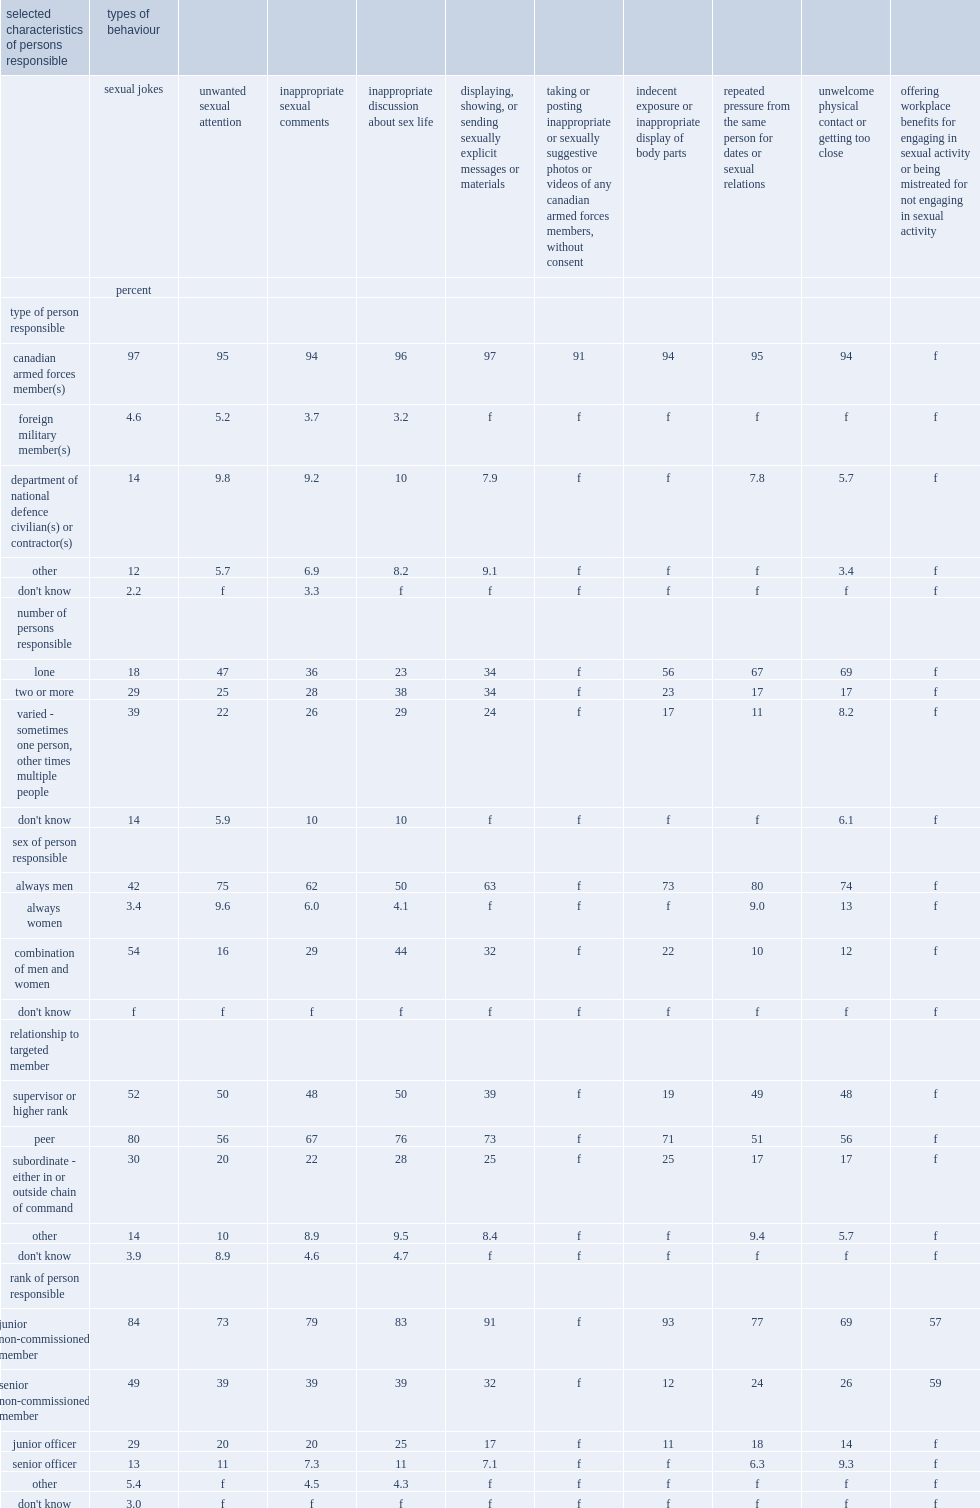What is the percentage of members reported that the person who perpetrated the repeated pressure for dates or sexual relationships that they experienced was always male? 80.0. What is the percentage of members who have personally experienced unwanted sexual attention reporting that the person was always male? 75.0. What is the percentage of reservists who have experienced targeted sexual jokes indicating that a combination of men and women are responsible? 54.0. What is the percentage of reservists who have experienced inappropriate discussion of their sex life indicating that a combination of men and women are responsible? 44.0. Could you parse the entire table? {'header': ['selected characteristics of persons responsible', 'types of behaviour', '', '', '', '', '', '', '', '', ''], 'rows': [['', 'sexual jokes', 'unwanted sexual attention', 'inappropriate sexual comments', 'inappropriate discussion about sex life', 'displaying, showing, or sending sexually explicit messages or materials', 'taking or posting inappropriate or sexually suggestive photos or videos of any canadian armed forces members, without consent', 'indecent exposure or inappropriate display of body parts', 'repeated pressure from the same person for dates or sexual relations', 'unwelcome physical contact or getting too close', 'offering workplace benefits for engaging in sexual activity or being mistreated for not engaging in sexual activity'], ['', 'percent', '', '', '', '', '', '', '', '', ''], ['type of person responsible', '', '', '', '', '', '', '', '', '', ''], ['canadian armed forces member(s)', '97', '95', '94', '96', '97', '91', '94', '95', '94', 'f'], ['foreign military member(s)', '4.6', '5.2', '3.7', '3.2', 'f', 'f', 'f', 'f', 'f', 'f'], ['department of national defence civilian(s) or contractor(s)', '14', '9.8', '9.2', '10', '7.9', 'f', 'f', '7.8', '5.7', 'f'], ['other', '12', '5.7', '6.9', '8.2', '9.1', 'f', 'f', 'f', '3.4', 'f'], ["don't know", '2.2', 'f', '3.3', 'f', 'f', 'f', 'f', 'f', 'f', 'f'], ['number of persons responsible', '', '', '', '', '', '', '', '', '', ''], ['lone', '18', '47', '36', '23', '34', 'f', '56', '67', '69', 'f'], ['two or more', '29', '25', '28', '38', '34', 'f', '23', '17', '17', 'f'], ['varied - sometimes one person, other times multiple people', '39', '22', '26', '29', '24', 'f', '17', '11', '8.2', 'f'], ["don't know", '14', '5.9', '10', '10', 'f', 'f', 'f', 'f', '6.1', 'f'], ['sex of person responsible', '', '', '', '', '', '', '', '', '', ''], ['always men', '42', '75', '62', '50', '63', 'f', '73', '80', '74', 'f'], ['always women', '3.4', '9.6', '6.0', '4.1', 'f', 'f', 'f', '9.0', '13', 'f'], ['combination of men and women', '54', '16', '29', '44', '32', 'f', '22', '10', '12', 'f'], ["don't know", 'f', 'f', 'f', 'f', 'f', 'f', 'f', 'f', 'f', 'f'], ['relationship to targeted member', '', '', '', '', '', '', '', '', '', ''], ['supervisor or higher rank', '52', '50', '48', '50', '39', 'f', '19', '49', '48', 'f'], ['peer', '80', '56', '67', '76', '73', 'f', '71', '51', '56', 'f'], ['subordinate - either in or outside chain of command', '30', '20', '22', '28', '25', 'f', '25', '17', '17', 'f'], ['other', '14', '10', '8.9', '9.5', '8.4', 'f', 'f', '9.4', '5.7', 'f'], ["don't know", '3.9', '8.9', '4.6', '4.7', 'f', 'f', 'f', 'f', 'f', 'f'], ['rank of person responsible', '', '', '', '', '', '', '', '', '', ''], ['junior non-commissioned member', '84', '73', '79', '83', '91', 'f', '93', '77', '69', '57'], ['senior non-commissioned member', '49', '39', '39', '39', '32', 'f', '12', '24', '26', '59'], ['junior officer', '29', '20', '20', '25', '17', 'f', '11', '18', '14', 'f'], ['senior officer', '13', '11', '7.3', '11', '7.1', 'f', 'f', '6.3', '9.3', 'f'], ['other', '5.4', 'f', '4.5', '4.3', 'f', 'f', 'f', 'f', 'f', 'f'], ["don't know", '3.0', 'f', 'f', 'f', 'f', 'f', 'f', 'f', 'f', 'f']]} 